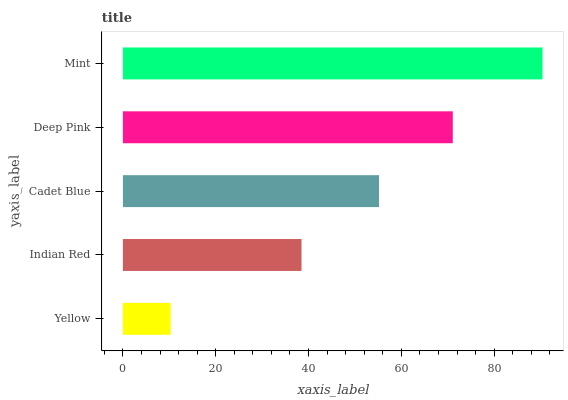Is Yellow the minimum?
Answer yes or no. Yes. Is Mint the maximum?
Answer yes or no. Yes. Is Indian Red the minimum?
Answer yes or no. No. Is Indian Red the maximum?
Answer yes or no. No. Is Indian Red greater than Yellow?
Answer yes or no. Yes. Is Yellow less than Indian Red?
Answer yes or no. Yes. Is Yellow greater than Indian Red?
Answer yes or no. No. Is Indian Red less than Yellow?
Answer yes or no. No. Is Cadet Blue the high median?
Answer yes or no. Yes. Is Cadet Blue the low median?
Answer yes or no. Yes. Is Yellow the high median?
Answer yes or no. No. Is Indian Red the low median?
Answer yes or no. No. 